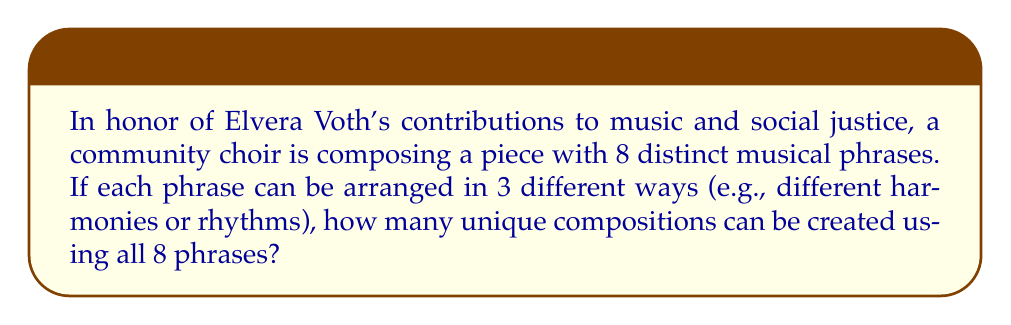Could you help me with this problem? Let's approach this step-by-step:

1) We have 8 distinct musical phrases, and each phrase can be arranged in 3 different ways.

2) For each phrase, we have 3 choices, independent of the choices for the other phrases.

3) This scenario follows the multiplication principle of counting. When we have a series of independent choices, we multiply the number of options for each choice.

4) In this case, we're making 8 independent choices (one for each phrase), and each choice has 3 options.

5) Therefore, the total number of possible compositions is:

   $$3 \times 3 \times 3 \times 3 \times 3 \times 3 \times 3 \times 3 = 3^8$$

6) We can calculate this:

   $$3^8 = 6,561$$

Thus, the choir can create 6,561 unique compositions using all 8 phrases, each arranged in one of 3 ways.
Answer: $3^8 = 6,561$ 